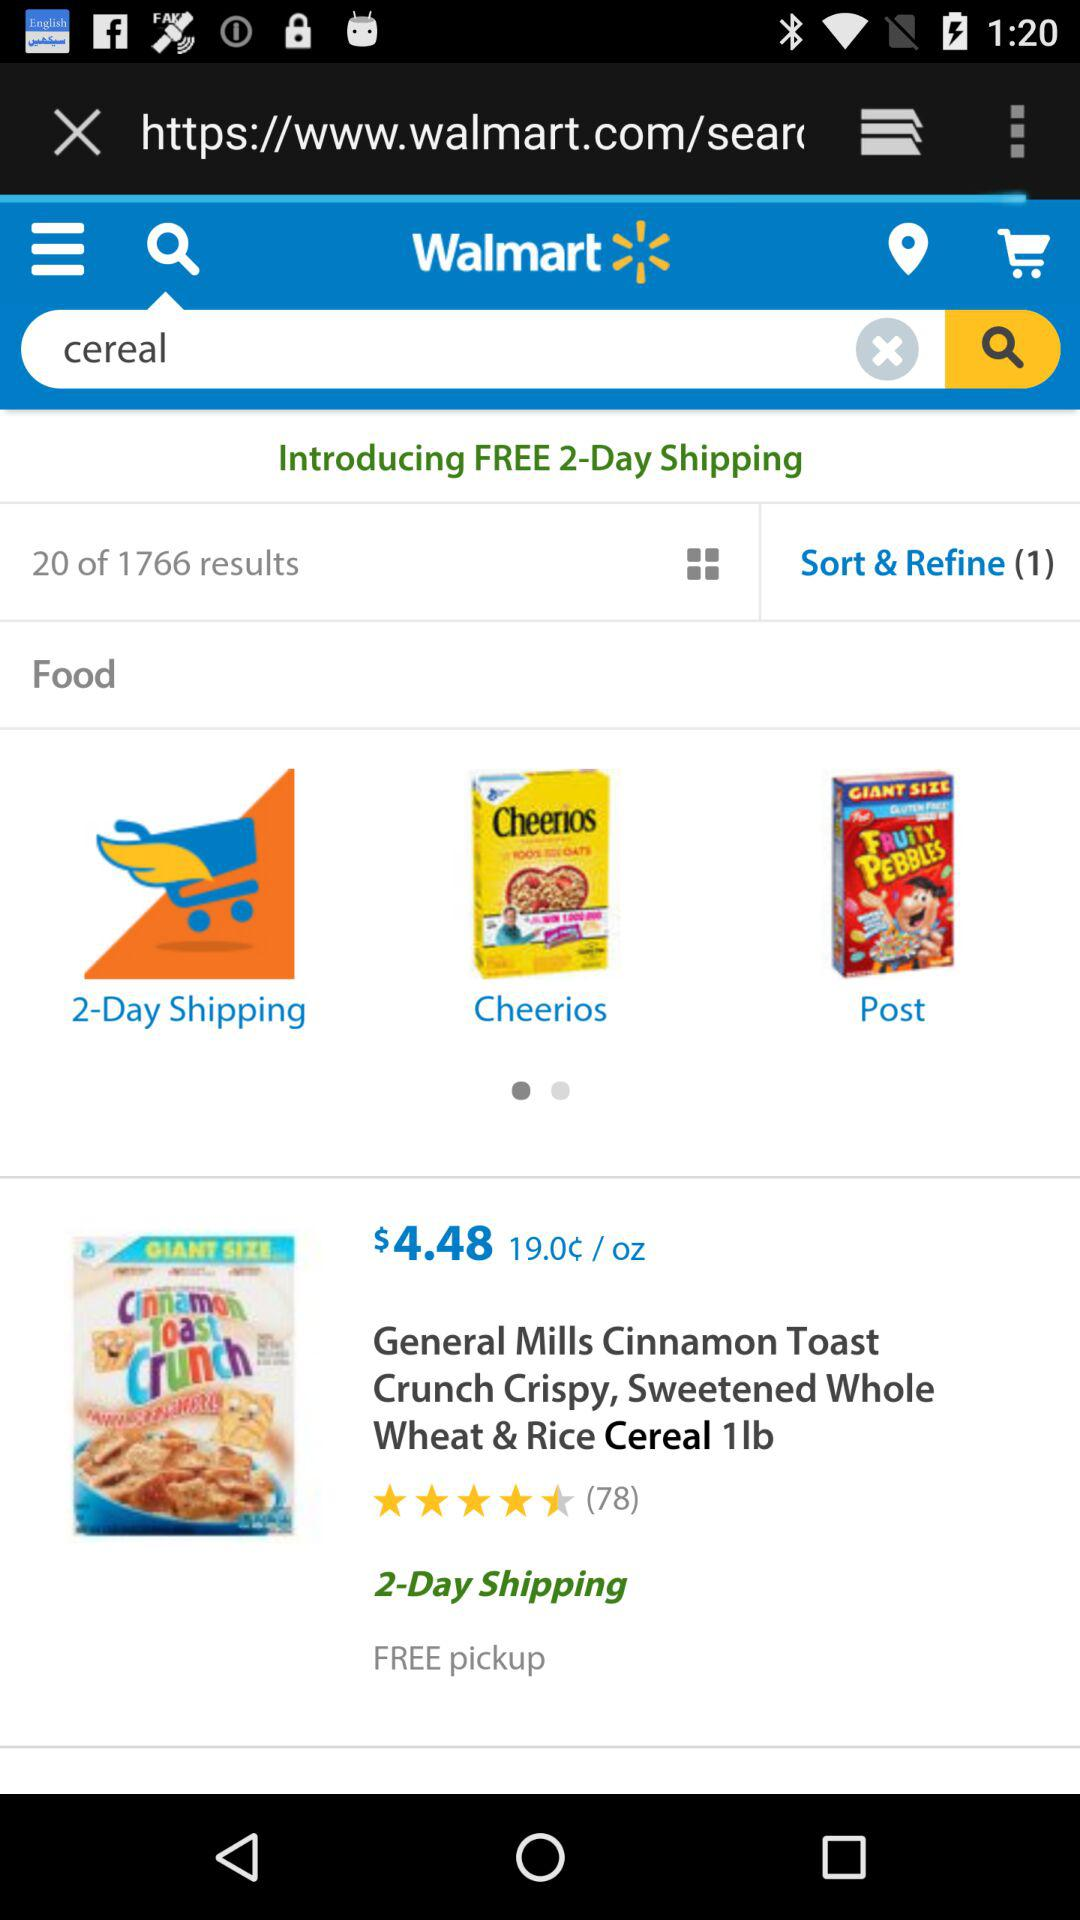Which page of results are we on? You are on page 20 of the results. 